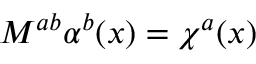<formula> <loc_0><loc_0><loc_500><loc_500>M ^ { a b } \alpha ^ { b } ( x ) = \chi ^ { a } ( x )</formula> 